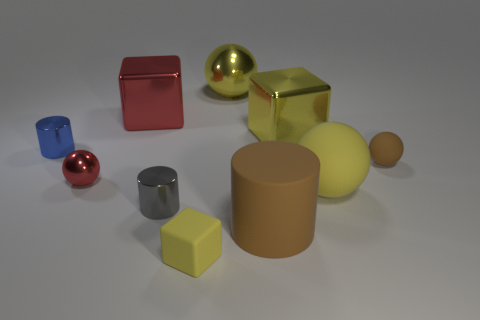What can you infer about the setting of this image? Based on the soft shadows and subdued reflections, it seems the image represents a controlled environment, likely constructed for the purpose of displaying the objects. There's no background context which implies that the setting is not meant to be part of the narrative. The focus is solely on the objects, and the neutral, solid color of the ground suggests a simplistic, distraction-free setting to emphasize the form and material of the objects. 